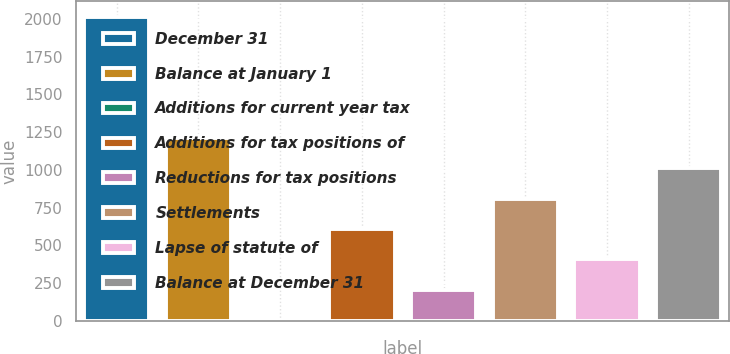Convert chart. <chart><loc_0><loc_0><loc_500><loc_500><bar_chart><fcel>December 31<fcel>Balance at January 1<fcel>Additions for current year tax<fcel>Additions for tax positions of<fcel>Reductions for tax positions<fcel>Settlements<fcel>Lapse of statute of<fcel>Balance at December 31<nl><fcel>2015<fcel>1211.8<fcel>7<fcel>609.4<fcel>207.8<fcel>810.2<fcel>408.6<fcel>1011<nl></chart> 